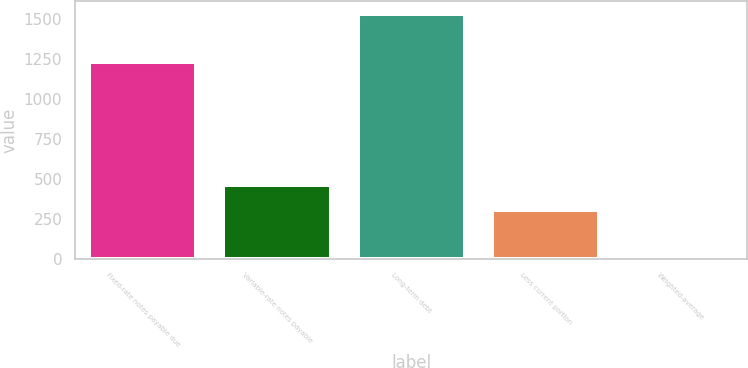Convert chart to OTSL. <chart><loc_0><loc_0><loc_500><loc_500><bar_chart><fcel>Fixed-rate notes payable due<fcel>Variable-rate notes payable<fcel>Long-term debt<fcel>Less current portion<fcel>Weighted-average<nl><fcel>1233.6<fcel>461.52<fcel>1534.2<fcel>308.28<fcel>1.8<nl></chart> 